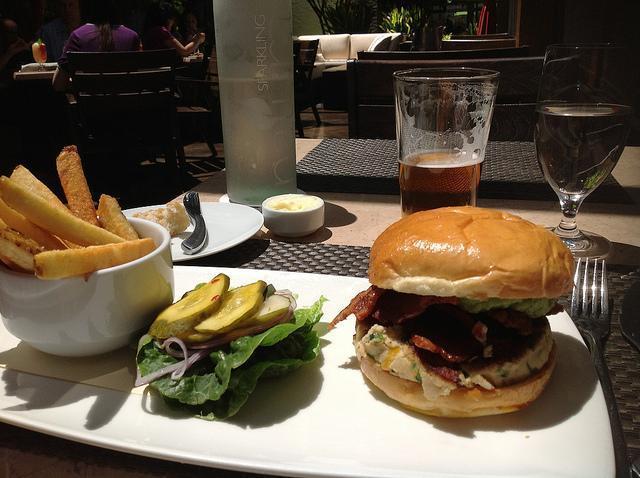How many sandwiches are there?
Give a very brief answer. 1. How many bowls are there?
Give a very brief answer. 2. How many dining tables are in the photo?
Give a very brief answer. 2. How many forks are there?
Give a very brief answer. 1. How many cups are in the photo?
Give a very brief answer. 1. How many chairs can you see?
Give a very brief answer. 3. How many bottles are there?
Give a very brief answer. 1. 